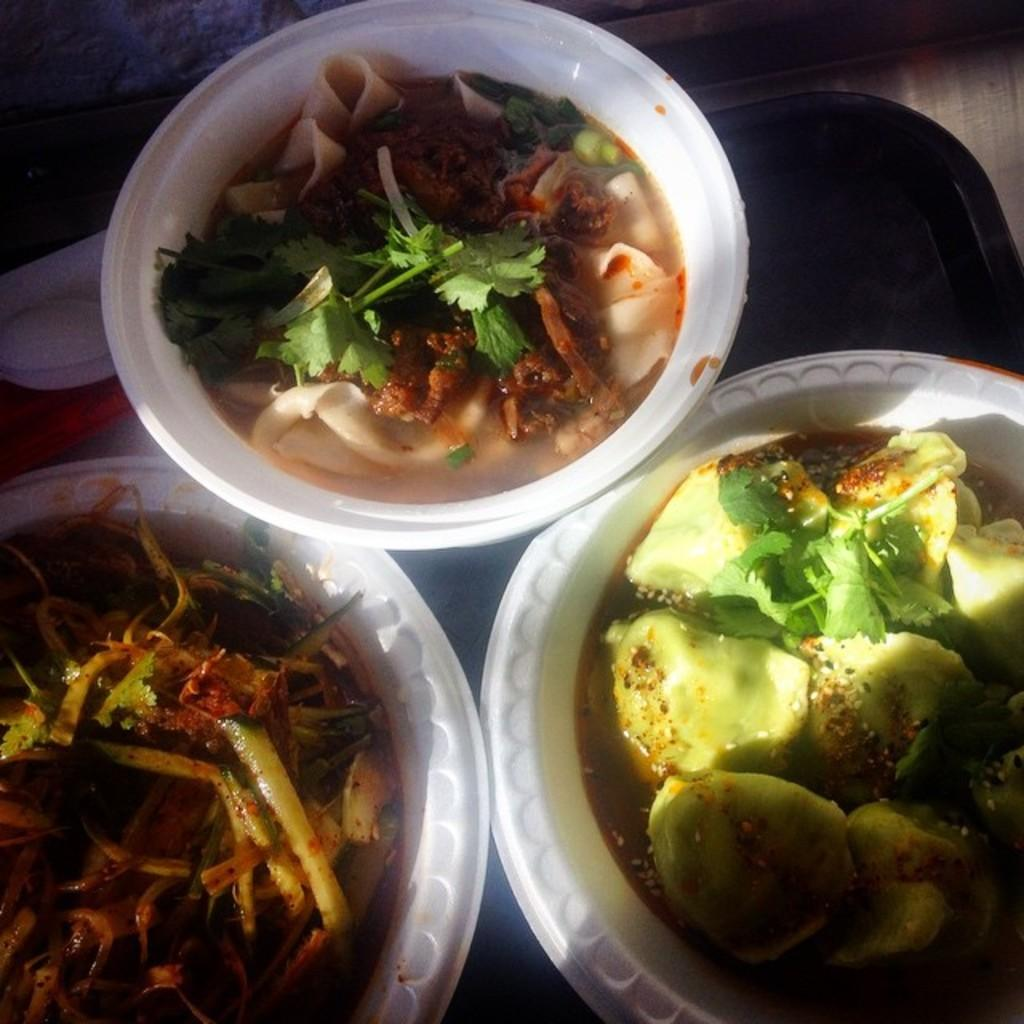What objects are present in the image that are used for serving food? There are serving plates in the image. What is on the serving plates? The serving plates contain food. How are the serving plates arranged in the image? The serving plates are placed on a tray. What type of cabbage is growing in the hole on the tray in the image? There is no cabbage or hole present on the tray in the image; it only contains serving plates with food. 